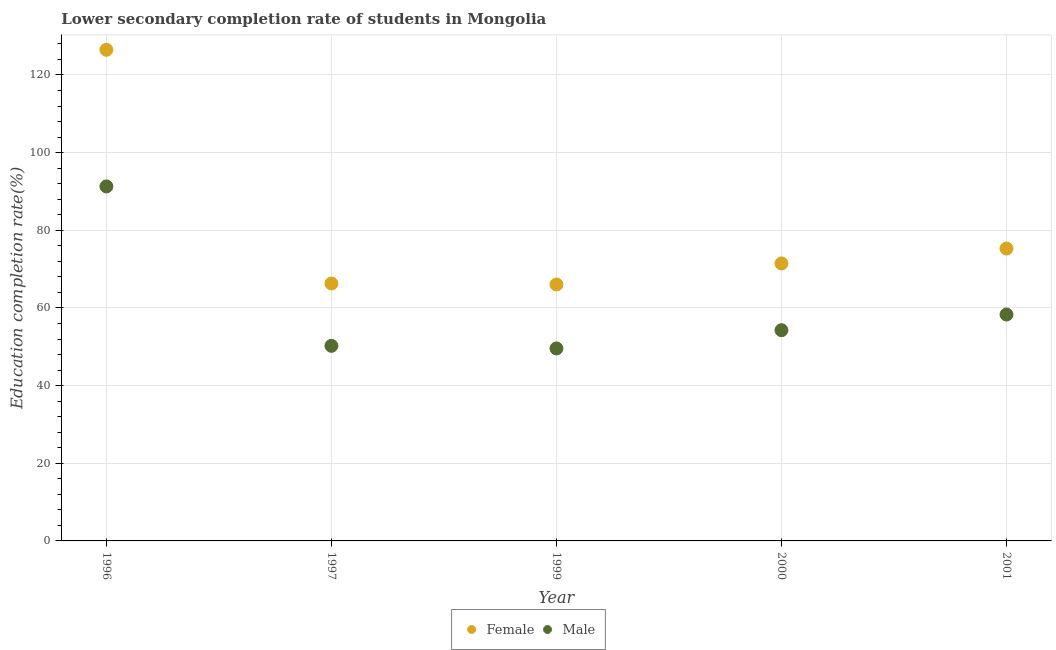How many different coloured dotlines are there?
Your response must be concise. 2. What is the education completion rate of female students in 1997?
Offer a terse response. 66.29. Across all years, what is the maximum education completion rate of female students?
Provide a succinct answer. 126.48. Across all years, what is the minimum education completion rate of female students?
Provide a short and direct response. 66.04. What is the total education completion rate of female students in the graph?
Provide a short and direct response. 405.57. What is the difference between the education completion rate of female students in 1999 and that in 2000?
Provide a short and direct response. -5.43. What is the difference between the education completion rate of female students in 2001 and the education completion rate of male students in 1999?
Your answer should be very brief. 25.72. What is the average education completion rate of male students per year?
Keep it short and to the point. 60.74. In the year 1997, what is the difference between the education completion rate of male students and education completion rate of female students?
Offer a very short reply. -16.05. What is the ratio of the education completion rate of female students in 1996 to that in 1999?
Offer a very short reply. 1.92. Is the difference between the education completion rate of female students in 1999 and 2000 greater than the difference between the education completion rate of male students in 1999 and 2000?
Offer a very short reply. No. What is the difference between the highest and the second highest education completion rate of female students?
Make the answer very short. 51.18. What is the difference between the highest and the lowest education completion rate of male students?
Your response must be concise. 41.72. In how many years, is the education completion rate of male students greater than the average education completion rate of male students taken over all years?
Keep it short and to the point. 1. Is the education completion rate of female students strictly greater than the education completion rate of male students over the years?
Ensure brevity in your answer.  Yes. Is the education completion rate of male students strictly less than the education completion rate of female students over the years?
Provide a succinct answer. Yes. How many dotlines are there?
Your answer should be compact. 2. What is the difference between two consecutive major ticks on the Y-axis?
Give a very brief answer. 20. Where does the legend appear in the graph?
Provide a succinct answer. Bottom center. What is the title of the graph?
Your answer should be compact. Lower secondary completion rate of students in Mongolia. Does "National Tourists" appear as one of the legend labels in the graph?
Keep it short and to the point. No. What is the label or title of the Y-axis?
Offer a very short reply. Education completion rate(%). What is the Education completion rate(%) in Female in 1996?
Provide a short and direct response. 126.48. What is the Education completion rate(%) of Male in 1996?
Offer a terse response. 91.29. What is the Education completion rate(%) in Female in 1997?
Offer a terse response. 66.29. What is the Education completion rate(%) in Male in 1997?
Keep it short and to the point. 50.24. What is the Education completion rate(%) in Female in 1999?
Offer a very short reply. 66.04. What is the Education completion rate(%) of Male in 1999?
Your response must be concise. 49.57. What is the Education completion rate(%) in Female in 2000?
Keep it short and to the point. 71.46. What is the Education completion rate(%) in Male in 2000?
Ensure brevity in your answer.  54.27. What is the Education completion rate(%) in Female in 2001?
Make the answer very short. 75.3. What is the Education completion rate(%) in Male in 2001?
Provide a short and direct response. 58.31. Across all years, what is the maximum Education completion rate(%) of Female?
Offer a very short reply. 126.48. Across all years, what is the maximum Education completion rate(%) in Male?
Your answer should be very brief. 91.29. Across all years, what is the minimum Education completion rate(%) of Female?
Your answer should be compact. 66.04. Across all years, what is the minimum Education completion rate(%) in Male?
Offer a very short reply. 49.57. What is the total Education completion rate(%) of Female in the graph?
Your response must be concise. 405.57. What is the total Education completion rate(%) of Male in the graph?
Ensure brevity in your answer.  303.68. What is the difference between the Education completion rate(%) in Female in 1996 and that in 1997?
Ensure brevity in your answer.  60.19. What is the difference between the Education completion rate(%) of Male in 1996 and that in 1997?
Provide a succinct answer. 41.05. What is the difference between the Education completion rate(%) of Female in 1996 and that in 1999?
Offer a very short reply. 60.44. What is the difference between the Education completion rate(%) in Male in 1996 and that in 1999?
Keep it short and to the point. 41.72. What is the difference between the Education completion rate(%) of Female in 1996 and that in 2000?
Provide a succinct answer. 55.01. What is the difference between the Education completion rate(%) in Male in 1996 and that in 2000?
Ensure brevity in your answer.  37.02. What is the difference between the Education completion rate(%) of Female in 1996 and that in 2001?
Your response must be concise. 51.18. What is the difference between the Education completion rate(%) of Male in 1996 and that in 2001?
Provide a succinct answer. 32.98. What is the difference between the Education completion rate(%) of Female in 1997 and that in 1999?
Your response must be concise. 0.25. What is the difference between the Education completion rate(%) of Male in 1997 and that in 1999?
Give a very brief answer. 0.66. What is the difference between the Education completion rate(%) in Female in 1997 and that in 2000?
Provide a succinct answer. -5.17. What is the difference between the Education completion rate(%) of Male in 1997 and that in 2000?
Make the answer very short. -4.03. What is the difference between the Education completion rate(%) of Female in 1997 and that in 2001?
Make the answer very short. -9.01. What is the difference between the Education completion rate(%) of Male in 1997 and that in 2001?
Give a very brief answer. -8.07. What is the difference between the Education completion rate(%) in Female in 1999 and that in 2000?
Your response must be concise. -5.43. What is the difference between the Education completion rate(%) of Male in 1999 and that in 2000?
Give a very brief answer. -4.69. What is the difference between the Education completion rate(%) in Female in 1999 and that in 2001?
Keep it short and to the point. -9.26. What is the difference between the Education completion rate(%) of Male in 1999 and that in 2001?
Your answer should be compact. -8.73. What is the difference between the Education completion rate(%) in Female in 2000 and that in 2001?
Keep it short and to the point. -3.83. What is the difference between the Education completion rate(%) in Male in 2000 and that in 2001?
Make the answer very short. -4.04. What is the difference between the Education completion rate(%) of Female in 1996 and the Education completion rate(%) of Male in 1997?
Your answer should be compact. 76.24. What is the difference between the Education completion rate(%) of Female in 1996 and the Education completion rate(%) of Male in 1999?
Offer a terse response. 76.9. What is the difference between the Education completion rate(%) in Female in 1996 and the Education completion rate(%) in Male in 2000?
Your answer should be very brief. 72.21. What is the difference between the Education completion rate(%) of Female in 1996 and the Education completion rate(%) of Male in 2001?
Make the answer very short. 68.17. What is the difference between the Education completion rate(%) in Female in 1997 and the Education completion rate(%) in Male in 1999?
Your answer should be very brief. 16.72. What is the difference between the Education completion rate(%) in Female in 1997 and the Education completion rate(%) in Male in 2000?
Provide a short and direct response. 12.02. What is the difference between the Education completion rate(%) of Female in 1997 and the Education completion rate(%) of Male in 2001?
Ensure brevity in your answer.  7.98. What is the difference between the Education completion rate(%) in Female in 1999 and the Education completion rate(%) in Male in 2000?
Provide a succinct answer. 11.77. What is the difference between the Education completion rate(%) of Female in 1999 and the Education completion rate(%) of Male in 2001?
Give a very brief answer. 7.73. What is the difference between the Education completion rate(%) of Female in 2000 and the Education completion rate(%) of Male in 2001?
Ensure brevity in your answer.  13.16. What is the average Education completion rate(%) in Female per year?
Your answer should be very brief. 81.11. What is the average Education completion rate(%) of Male per year?
Your answer should be very brief. 60.74. In the year 1996, what is the difference between the Education completion rate(%) of Female and Education completion rate(%) of Male?
Provide a short and direct response. 35.19. In the year 1997, what is the difference between the Education completion rate(%) of Female and Education completion rate(%) of Male?
Keep it short and to the point. 16.05. In the year 1999, what is the difference between the Education completion rate(%) in Female and Education completion rate(%) in Male?
Your answer should be very brief. 16.46. In the year 2000, what is the difference between the Education completion rate(%) of Female and Education completion rate(%) of Male?
Your answer should be compact. 17.2. In the year 2001, what is the difference between the Education completion rate(%) of Female and Education completion rate(%) of Male?
Keep it short and to the point. 16.99. What is the ratio of the Education completion rate(%) of Female in 1996 to that in 1997?
Your answer should be compact. 1.91. What is the ratio of the Education completion rate(%) of Male in 1996 to that in 1997?
Your response must be concise. 1.82. What is the ratio of the Education completion rate(%) of Female in 1996 to that in 1999?
Provide a succinct answer. 1.92. What is the ratio of the Education completion rate(%) in Male in 1996 to that in 1999?
Your answer should be very brief. 1.84. What is the ratio of the Education completion rate(%) in Female in 1996 to that in 2000?
Make the answer very short. 1.77. What is the ratio of the Education completion rate(%) in Male in 1996 to that in 2000?
Provide a succinct answer. 1.68. What is the ratio of the Education completion rate(%) of Female in 1996 to that in 2001?
Give a very brief answer. 1.68. What is the ratio of the Education completion rate(%) of Male in 1996 to that in 2001?
Give a very brief answer. 1.57. What is the ratio of the Education completion rate(%) of Female in 1997 to that in 1999?
Provide a short and direct response. 1. What is the ratio of the Education completion rate(%) in Male in 1997 to that in 1999?
Your response must be concise. 1.01. What is the ratio of the Education completion rate(%) in Female in 1997 to that in 2000?
Your answer should be compact. 0.93. What is the ratio of the Education completion rate(%) of Male in 1997 to that in 2000?
Provide a short and direct response. 0.93. What is the ratio of the Education completion rate(%) of Female in 1997 to that in 2001?
Provide a succinct answer. 0.88. What is the ratio of the Education completion rate(%) of Male in 1997 to that in 2001?
Provide a short and direct response. 0.86. What is the ratio of the Education completion rate(%) of Female in 1999 to that in 2000?
Keep it short and to the point. 0.92. What is the ratio of the Education completion rate(%) in Male in 1999 to that in 2000?
Your response must be concise. 0.91. What is the ratio of the Education completion rate(%) of Female in 1999 to that in 2001?
Give a very brief answer. 0.88. What is the ratio of the Education completion rate(%) in Male in 1999 to that in 2001?
Ensure brevity in your answer.  0.85. What is the ratio of the Education completion rate(%) in Female in 2000 to that in 2001?
Give a very brief answer. 0.95. What is the ratio of the Education completion rate(%) in Male in 2000 to that in 2001?
Your answer should be compact. 0.93. What is the difference between the highest and the second highest Education completion rate(%) of Female?
Offer a very short reply. 51.18. What is the difference between the highest and the second highest Education completion rate(%) in Male?
Your answer should be compact. 32.98. What is the difference between the highest and the lowest Education completion rate(%) of Female?
Give a very brief answer. 60.44. What is the difference between the highest and the lowest Education completion rate(%) in Male?
Offer a very short reply. 41.72. 